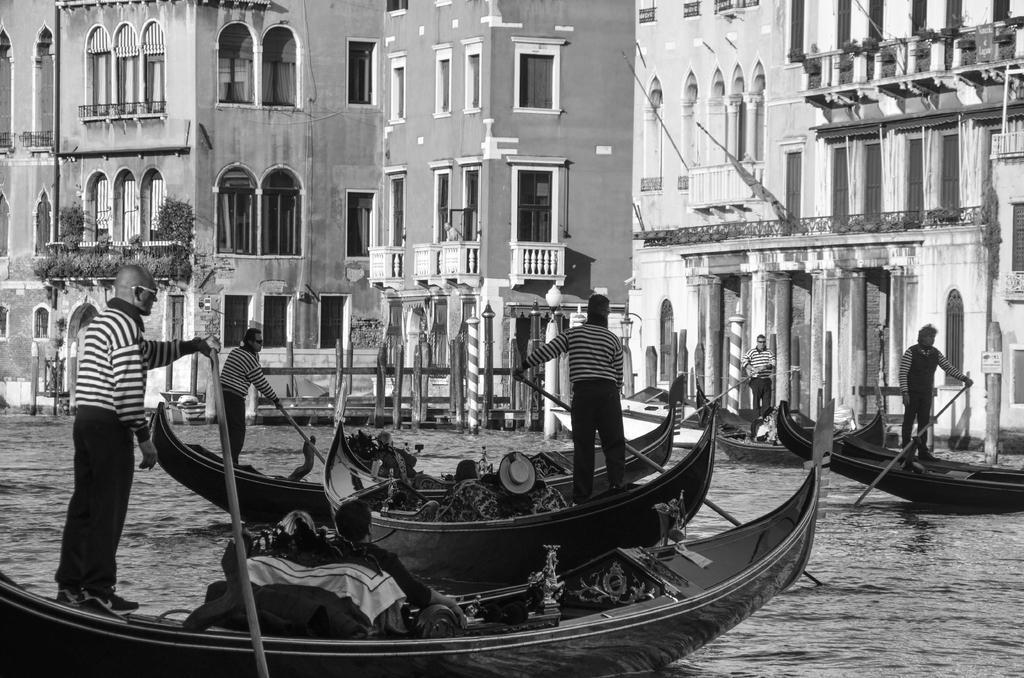Can you describe this image briefly? In this picture I can see boats on the water, there are group of people standing on the boats and holding the paddles, and in the background there are buildings ,plants. 